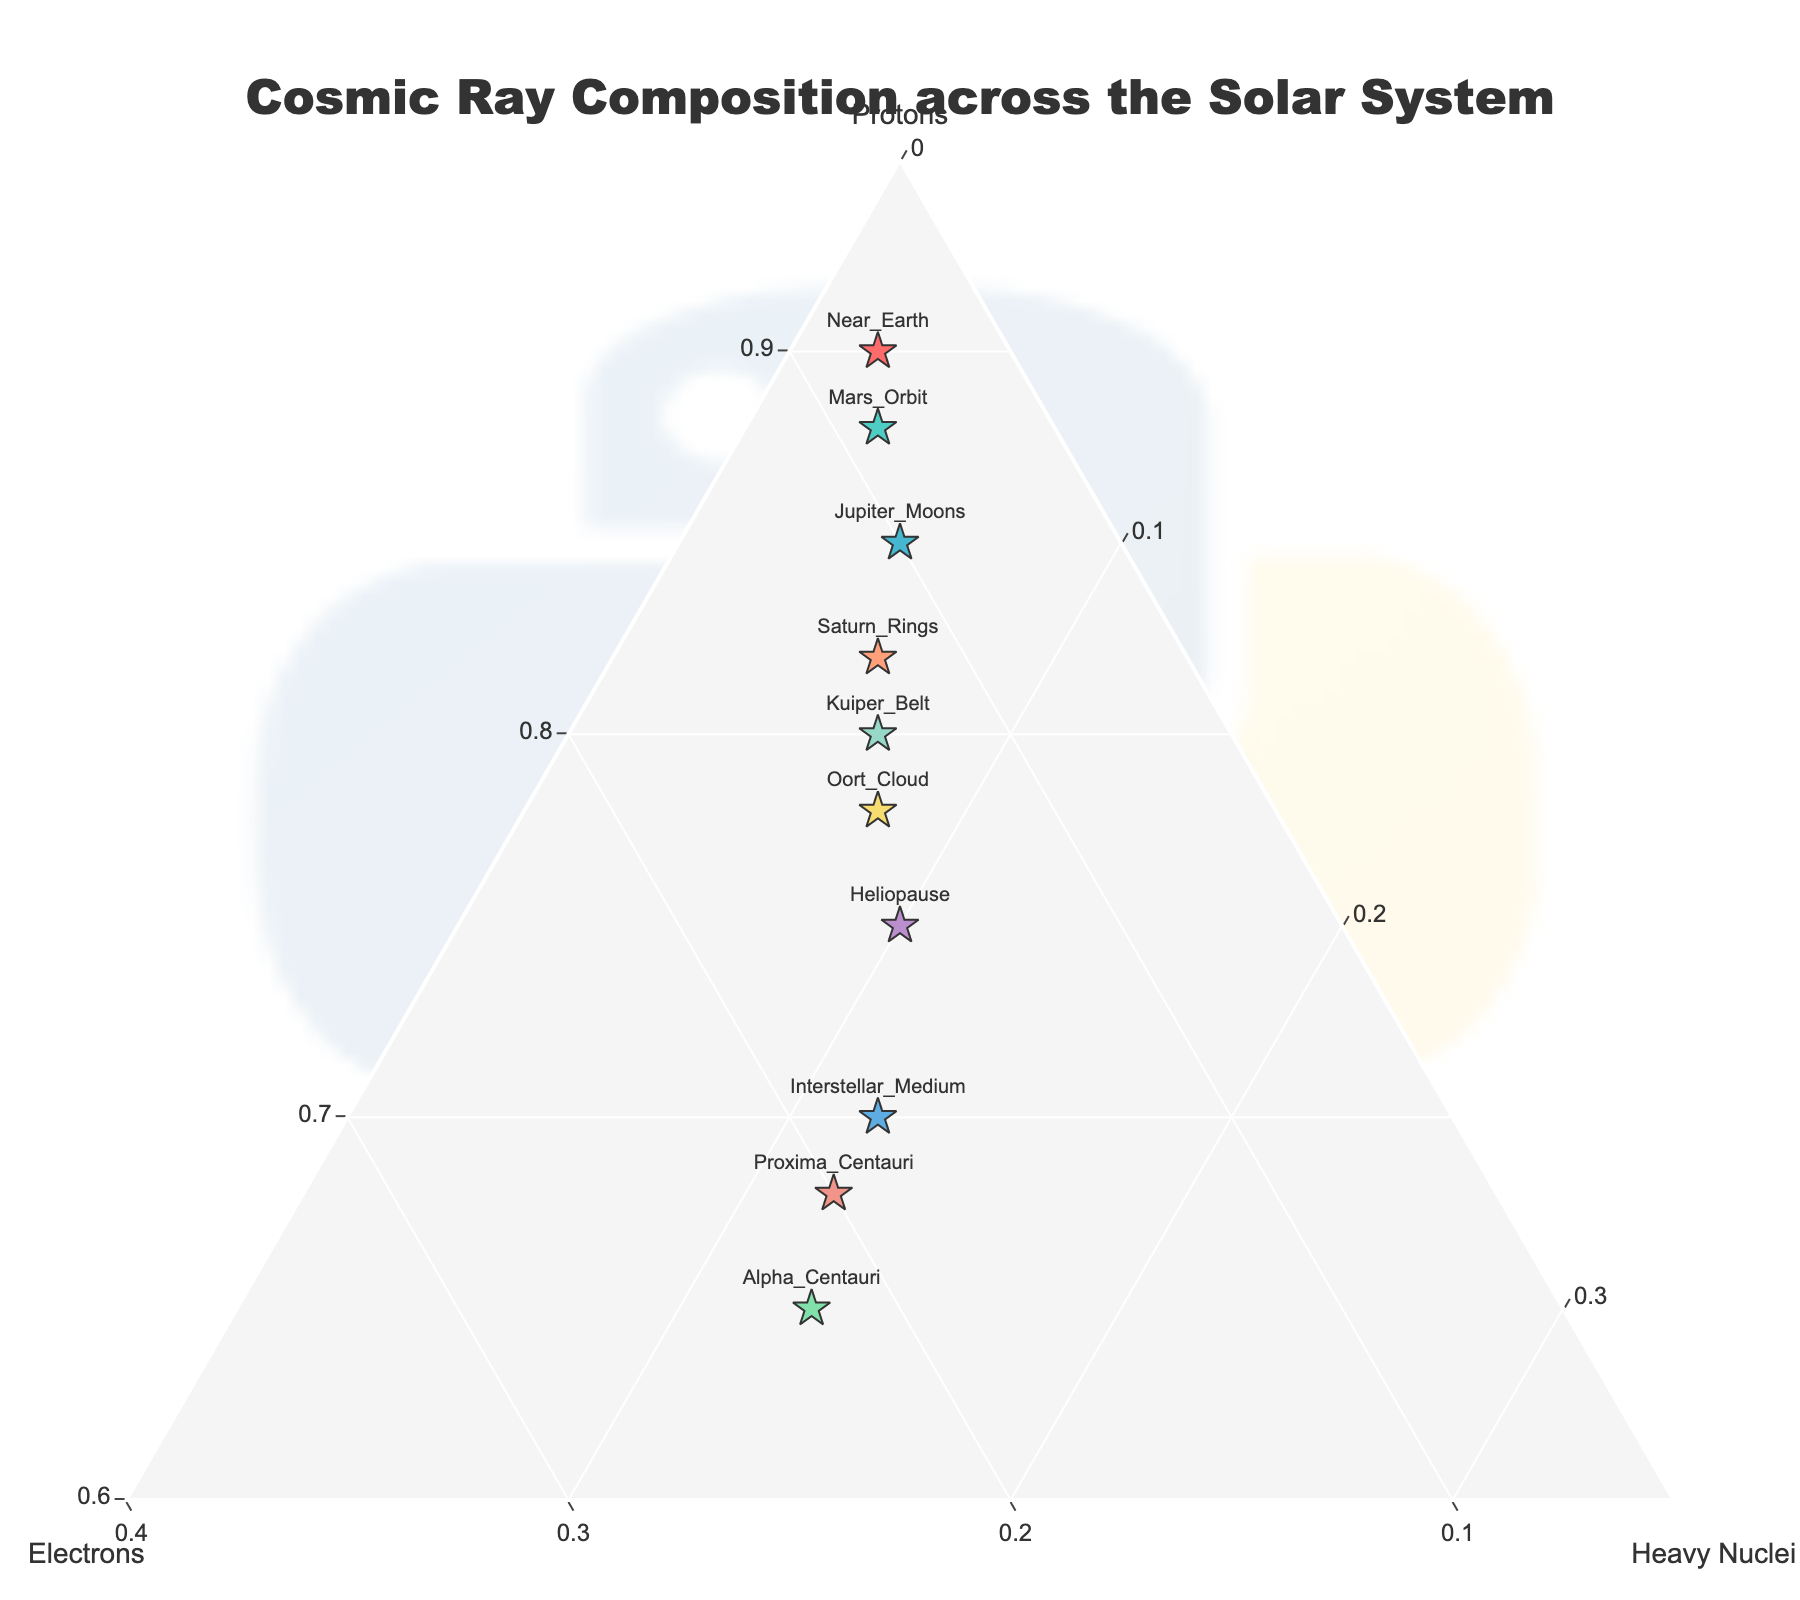what is the title of the plot? The title of the plot should be prominently displayed at the top. It reads: "Cosmic Ray Composition across the Solar System".
Answer: Cosmic Ray Composition across the Solar System How many different locations are represented in the ternary plot? By counting the labeled points in the ternary plot, you can determine the number of data points, which corresponds to the different locations. There are ten labeled points.
Answer: Ten What is the background color of the ternary plot? The background color of the ternary plot is light gray, as specified in the layout settings: 'bgcolor': '#F5F5F5'.
Answer: Light Gray Which location has the highest proportion of electrons? To find this, look at the ternary plot and identify the point that is closest to the 'Electrons' axis with the highest percentage. The location with the highest proportion of electrons is Alpha_Centauri at 0.22.
Answer: Alpha_Centauri Compare the proportions of heavy nuclei between Near_Earth and Proxima_Centauri. Which location has a higher proportion? By looking at the points labeled Near_Earth and Proxima_Centauri on the plot and referencing their respective values for Heavy_Nuclei, Near_Earth has 0.02 and Proxima_Centauri has 0.12. Proxima_Centauri has the higher proportion.
Answer: Proxima_Centauri What is the combined proportion of electrons in Mars_Orbit and Saturn_Rings? Sum the proportion of electrons found in Mars_Orbit (0.09) and Saturn_Rings (0.12). 0.09 + 0.12 = 0.21.
Answer: 0.21 Which location has the lowest proportion of protons? By examining the plot, the point furthest away from the 'Protons' axis and closest to the other two axes will have the lowest proportion. The location with the lowest proportion of protons is Alpha_Centauri with 0.65.
Answer: Alpha_Centauri Is there any location where the proportion of heavy nuclei exceeds the proportion of electrons? By reviewing all the proportions, no location has a higher proportion of heavy nuclei than electrons.
Answer: No Which two locations have the closest proportions of protons? By comparing the proportions of protons for all pairs of locations, Mars_Orbit (0.88) and Near_Earth (0.90) have the closest proportions, differing by only 0.02.
Answer: Mars_Orbit and Near_Earth What is the range of proportions for protons across all locations? The range can be found by subtracting the smallest proportion of protons (Alpha_Centauri, 0.65) from the largest proportion of protons (Near_Earth, 0.90). 0.90 - 0.65 = 0.25.
Answer: 0.25 